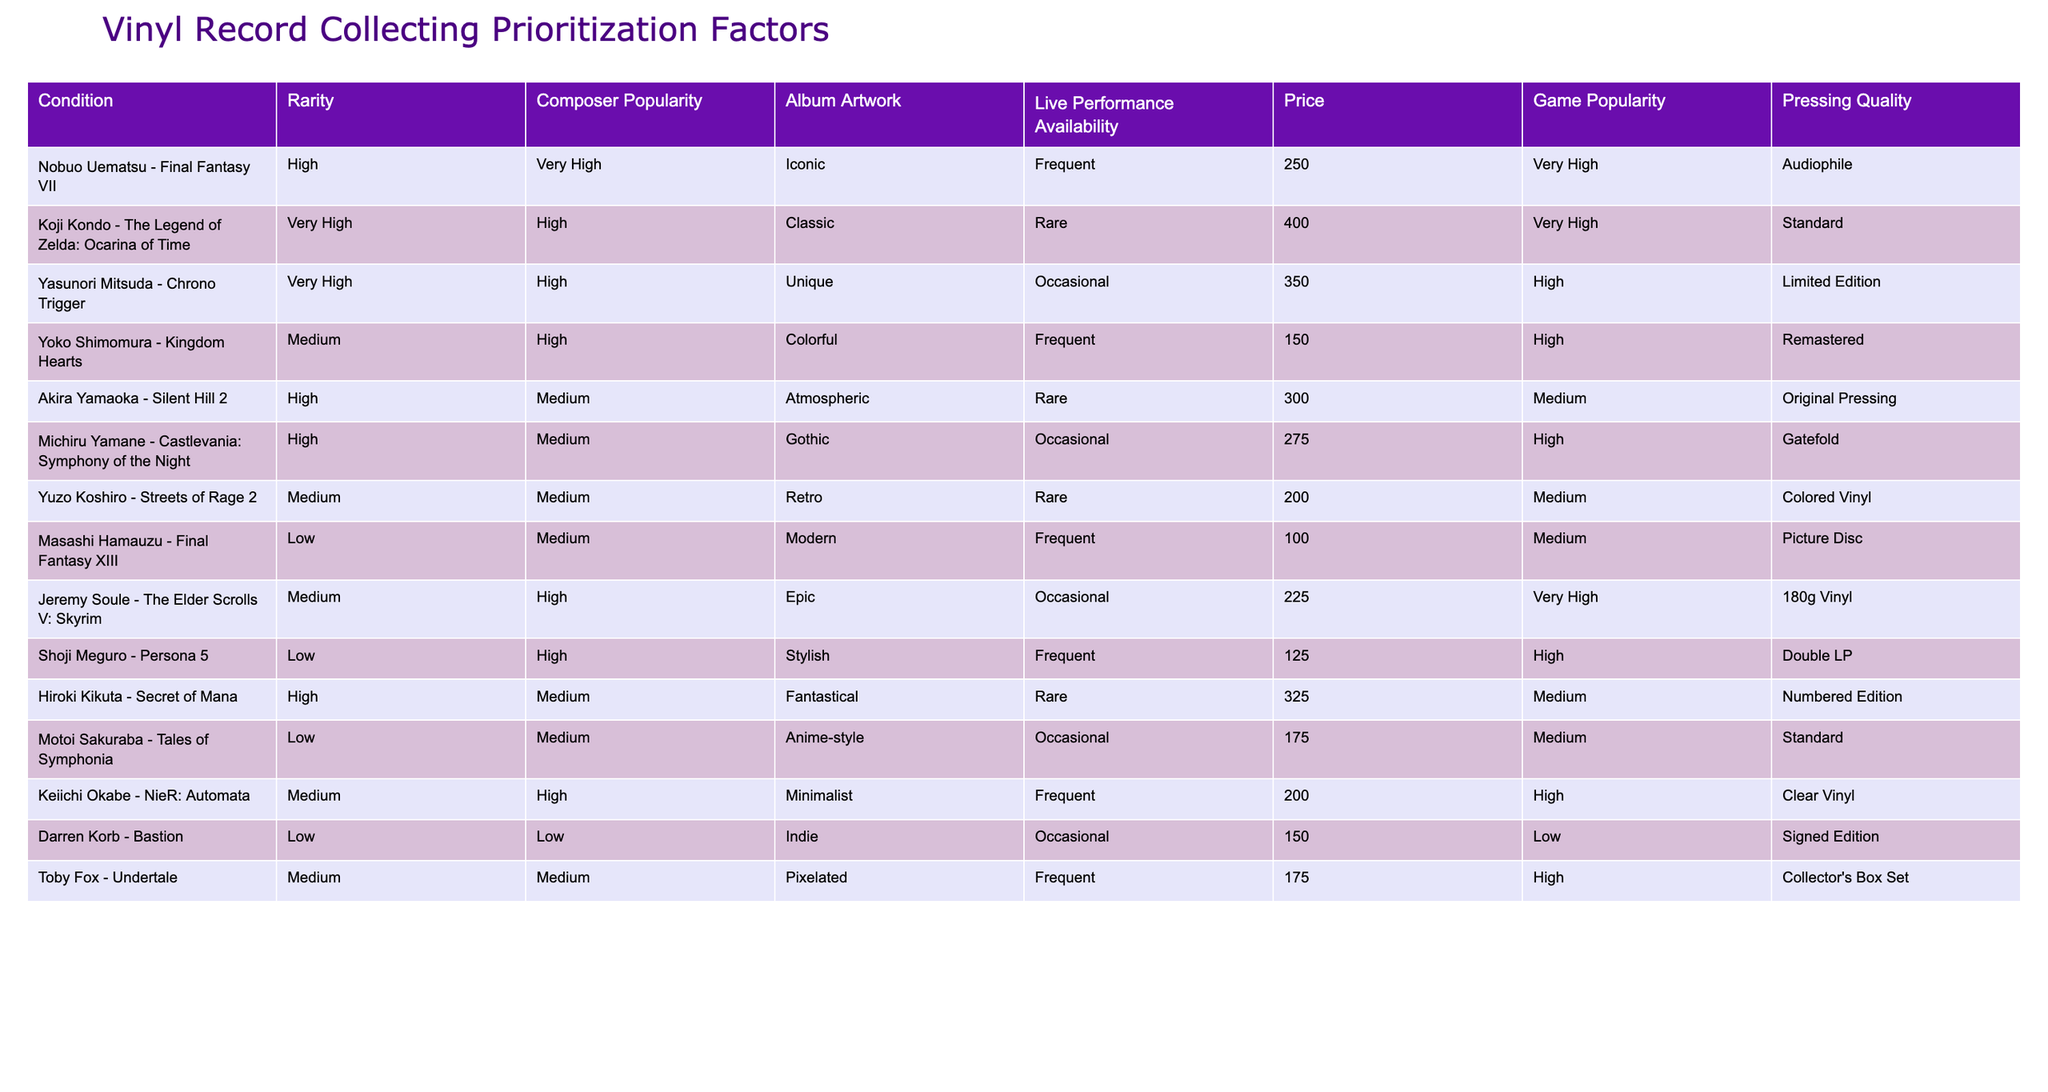What is the price of the album by Nobuo Uematsu? The table lists the price of the album "Final Fantasy VII" by Nobuo Uematsu as 250.
Answer: 250 Which composer has the highest rarity rating for their album? The highest rarity rating in the table is "Very High," which is associated with both Koji Kondo and Yasunori Mitsuda. Thus, both have the highest rarity rating.
Answer: Koji Kondo and Yasunori Mitsuda Are there any albums available in frequent live performances with a price below 200? The table shows that all albums listed as frequent live performances (Yoko Shimomura, Masashi Hamauzu, and Keiichi Okabe) have prices of 150, 100, and 200 respectively. Masashi Hamauzu's album is the only one below 200.
Answer: Yes What is the average price for albums rated as "Medium" in rarity? The albums with "Medium" rarity are priced at: 150 (Shoji Meguro), 200 (Yuzo Koshiro), 175 (Toby Fox), 100 (Masashi Hamauzu), and 225 (Jeremy Soule). The sum of these prices is 150 + 200 + 175 + 100 + 225 = 850, and there are 5 albums, so the average is 850/5 = 170.
Answer: 170 Which album has the best pressing quality among those with "High" composer popularity? Among the albums with "High" composer popularity, we have Akira Yamaoka (Original Pressing), Yasunori Mitsuda (Limited Edition), Hiroki Kikuta (Numbered Edition), Yoko Shimomura (Remastered), and Keiichi Okabe (Clear Vinyl). The best quality in this category is "Original Pressing" by Akira Yamaoka.
Answer: Akira Yamaoka - Silent Hill 2 How many albums have "Rare" availability for live performances? In the table, two albums have "Rare" live performance availability: Koji Kondo's "Ocarina of Time" and Akira Yamaoka's "Silent Hill 2." Therefore, there are two albums in this category.
Answer: 2 Is there an album associated with both a "Very High" rating in game popularity and "Frequent" live performance availability? The album by Jeremy Soule - "Skyrim" is "Very High" in game popularity and tagged as having "Occasional" live performance availability, but no album fulfills both criteria of "Very High" in game popularity and "Frequent" live performance availability.
Answer: No Which two composers have albums that have both "Very High" rarity and "High" composer popularity? The albums with "Very High" rarity and "High" composer popularity are Yasunori Mitsuda's "Chrono Trigger" and Koji Kondo's "The Legend of Zelda: Ocarina of Time." Both have been identified in these columns.
Answer: Yasunori Mitsuda and Koji Kondo 